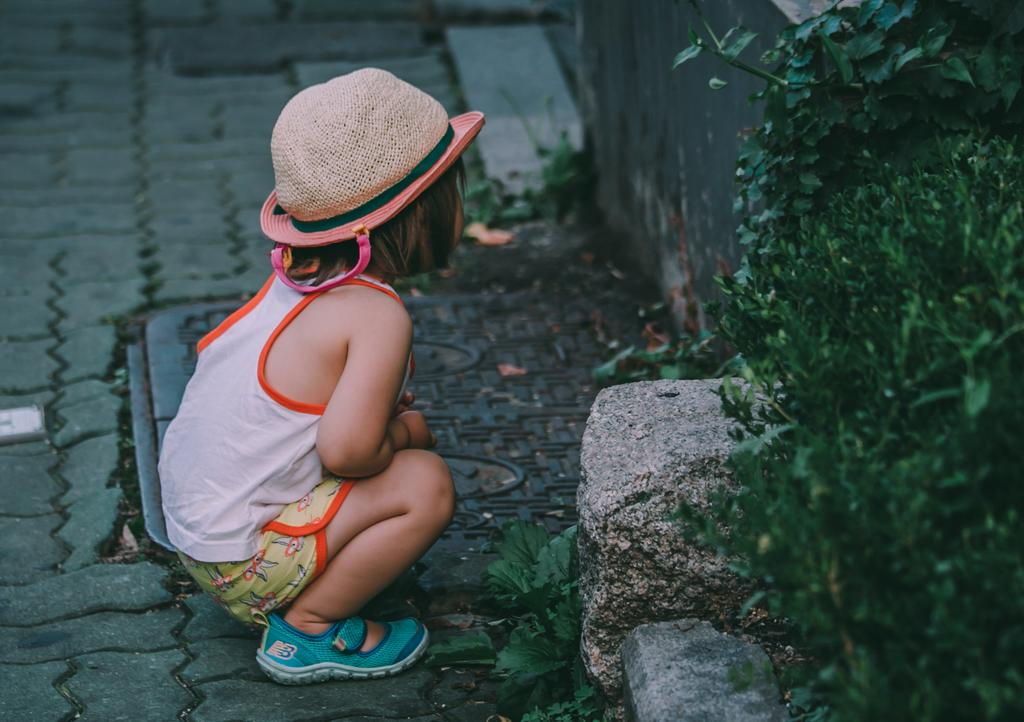What is the main subject of the image? There is a baby girl in the image. How is the baby girl positioned in the image? The baby girl is sitting on the floor in a squatting position. What can be seen behind the baby girl? There is a wall in front of the girl. What type of vegetation is present in the image? There are plants beside the wall. What type of drum can be seen in the baby girl's pocket in the image? There is no drum or pocket present in the image; the baby girl is simply sitting on the floor. 